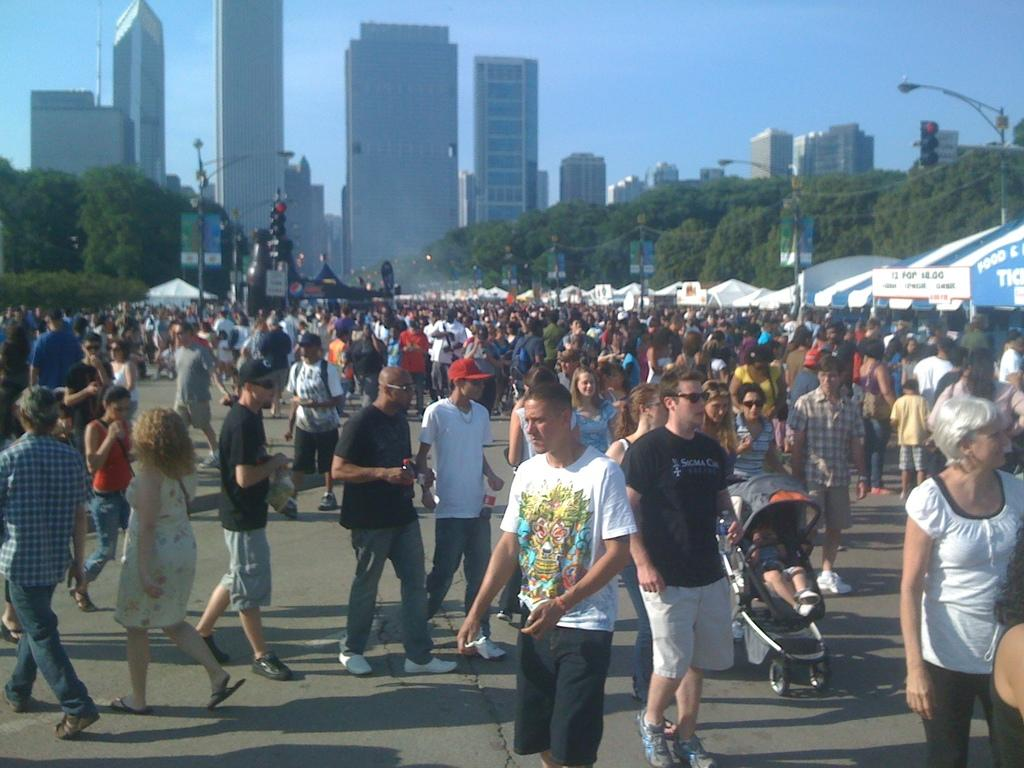What is the main subject of the image? The main subject of the image is a crowd. What can be seen in the background of the image? There are trees and buildings in the background of the image. What is the color of the sky in the image? The sky is blue in the image. How many plants are being used as chess pieces in the image? There are no plants or chess pieces present in the image. 